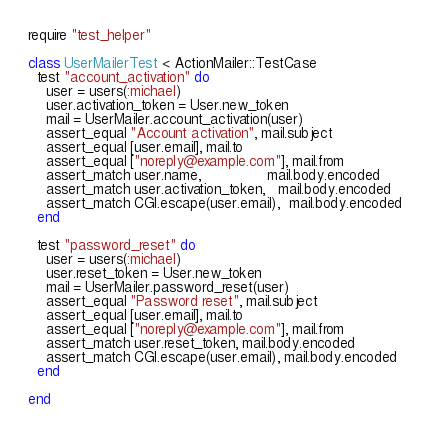<code> <loc_0><loc_0><loc_500><loc_500><_Ruby_>require "test_helper"

class UserMailerTest < ActionMailer::TestCase
  test "account_activation" do
    user = users(:michael)
    user.activation_token = User.new_token
    mail = UserMailer.account_activation(user)
    assert_equal "Account activation", mail.subject 
    assert_equal [user.email], mail.to
    assert_equal ["noreply@example.com"], mail.from
    assert_match user.name,               mail.body.encoded
    assert_match user.activation_token,   mail.body.encoded
    assert_match CGI.escape(user.email),  mail.body.encoded
  end

  test "password_reset" do 
    user = users(:michael)
    user.reset_token = User.new_token 
    mail = UserMailer.password_reset(user)
    assert_equal "Password reset", mail.subject 
    assert_equal [user.email], mail.to
    assert_equal ["noreply@example.com"], mail.from
    assert_match user.reset_token, mail.body.encoded 
    assert_match CGI.escape(user.email), mail.body.encoded
  end

end
</code> 